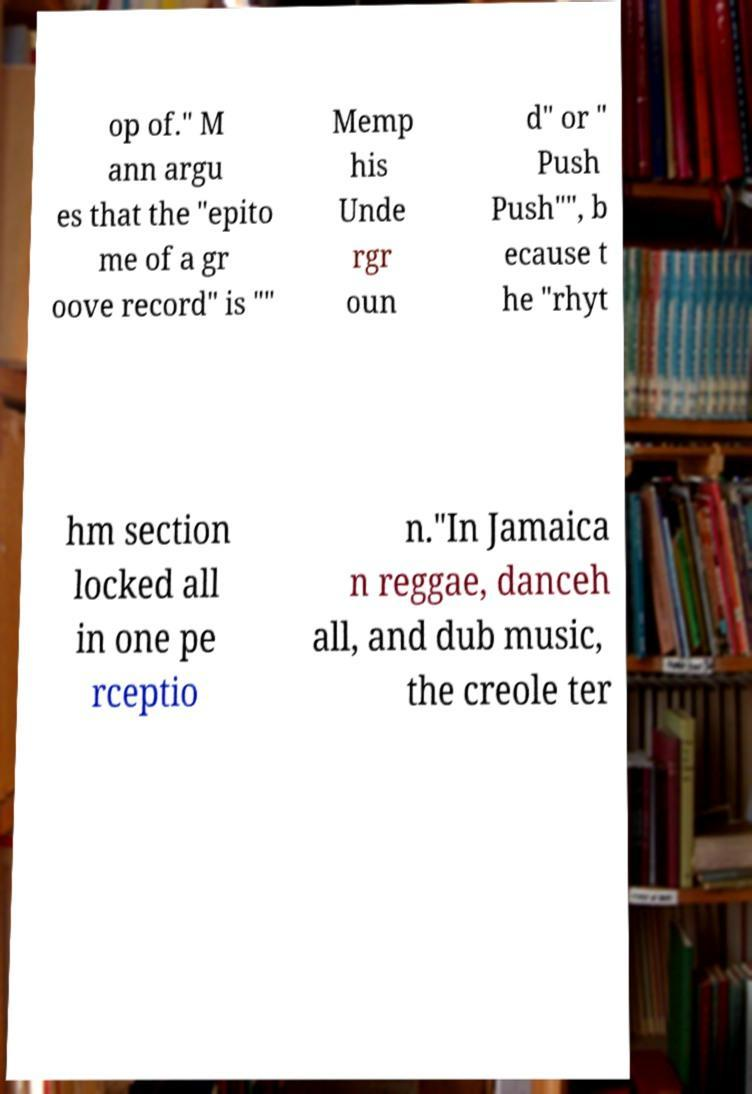Please read and relay the text visible in this image. What does it say? op of." M ann argu es that the "epito me of a gr oove record" is "" Memp his Unde rgr oun d" or " Push Push"", b ecause t he "rhyt hm section locked all in one pe rceptio n."In Jamaica n reggae, danceh all, and dub music, the creole ter 